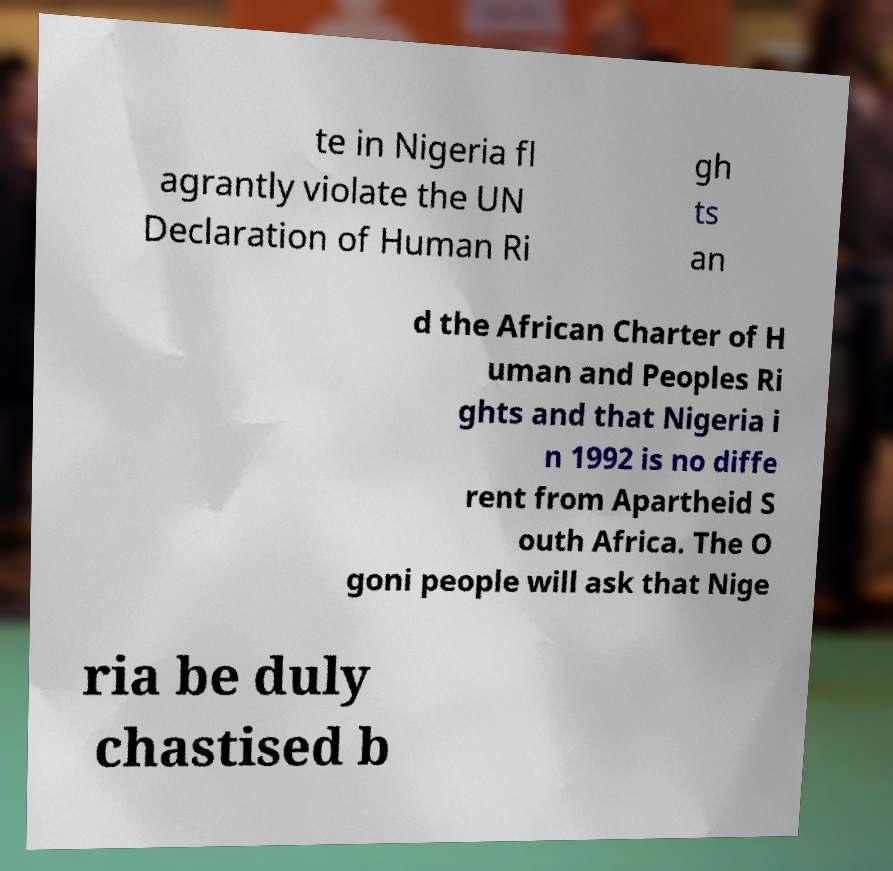For documentation purposes, I need the text within this image transcribed. Could you provide that? te in Nigeria fl agrantly violate the UN Declaration of Human Ri gh ts an d the African Charter of H uman and Peoples Ri ghts and that Nigeria i n 1992 is no diffe rent from Apartheid S outh Africa. The O goni people will ask that Nige ria be duly chastised b 